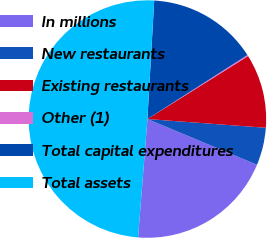Convert chart to OTSL. <chart><loc_0><loc_0><loc_500><loc_500><pie_chart><fcel>In millions<fcel>New restaurants<fcel>Existing restaurants<fcel>Other (1)<fcel>Total capital expenditures<fcel>Total assets<nl><fcel>19.97%<fcel>5.12%<fcel>10.07%<fcel>0.17%<fcel>15.02%<fcel>49.66%<nl></chart> 